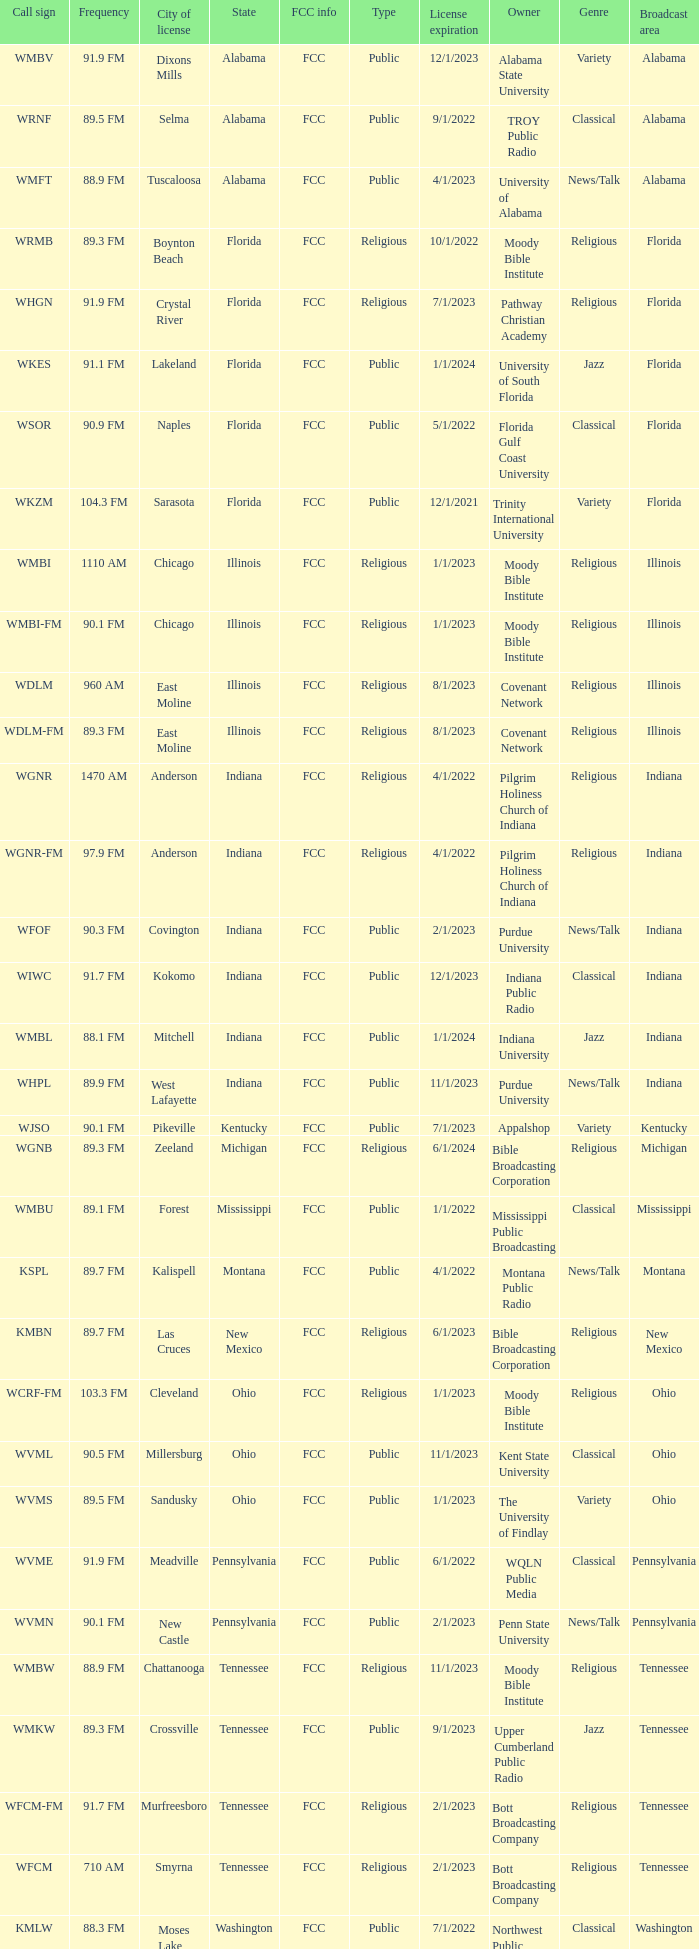What state is the radio station in that has a frequency of 90.1 FM and a city license in New Castle? Pennsylvania. Can you parse all the data within this table? {'header': ['Call sign', 'Frequency', 'City of license', 'State', 'FCC info', 'Type', 'License expiration', 'Owner', 'Genre', 'Broadcast area'], 'rows': [['WMBV', '91.9 FM', 'Dixons Mills', 'Alabama', 'FCC', 'Public', '12/1/2023', 'Alabama State University', 'Variety', 'Alabama'], ['WRNF', '89.5 FM', 'Selma', 'Alabama', 'FCC', 'Public', '9/1/2022', 'TROY Public Radio', 'Classical', 'Alabama'], ['WMFT', '88.9 FM', 'Tuscaloosa', 'Alabama', 'FCC', 'Public', '4/1/2023', 'University of Alabama', 'News/Talk', 'Alabama'], ['WRMB', '89.3 FM', 'Boynton Beach', 'Florida', 'FCC', 'Religious', '10/1/2022', 'Moody Bible Institute', 'Religious', 'Florida'], ['WHGN', '91.9 FM', 'Crystal River', 'Florida', 'FCC', 'Religious', '7/1/2023', 'Pathway Christian Academy', 'Religious', 'Florida'], ['WKES', '91.1 FM', 'Lakeland', 'Florida', 'FCC', 'Public', '1/1/2024', 'University of South Florida', 'Jazz', 'Florida'], ['WSOR', '90.9 FM', 'Naples', 'Florida', 'FCC', 'Public', '5/1/2022', 'Florida Gulf Coast University', 'Classical', 'Florida'], ['WKZM', '104.3 FM', 'Sarasota', 'Florida', 'FCC', 'Public', '12/1/2021', 'Trinity International University', 'Variety', 'Florida'], ['WMBI', '1110 AM', 'Chicago', 'Illinois', 'FCC', 'Religious', '1/1/2023', 'Moody Bible Institute', 'Religious', 'Illinois'], ['WMBI-FM', '90.1 FM', 'Chicago', 'Illinois', 'FCC', 'Religious', '1/1/2023', 'Moody Bible Institute', 'Religious', 'Illinois'], ['WDLM', '960 AM', 'East Moline', 'Illinois', 'FCC', 'Religious', '8/1/2023', 'Covenant Network', 'Religious', 'Illinois'], ['WDLM-FM', '89.3 FM', 'East Moline', 'Illinois', 'FCC', 'Religious', '8/1/2023', 'Covenant Network', 'Religious', 'Illinois'], ['WGNR', '1470 AM', 'Anderson', 'Indiana', 'FCC', 'Religious', '4/1/2022', 'Pilgrim Holiness Church of Indiana', 'Religious', 'Indiana'], ['WGNR-FM', '97.9 FM', 'Anderson', 'Indiana', 'FCC', 'Religious', '4/1/2022', 'Pilgrim Holiness Church of Indiana', 'Religious', 'Indiana'], ['WFOF', '90.3 FM', 'Covington', 'Indiana', 'FCC', 'Public', '2/1/2023', 'Purdue University', 'News/Talk', 'Indiana'], ['WIWC', '91.7 FM', 'Kokomo', 'Indiana', 'FCC', 'Public', '12/1/2023', 'Indiana Public Radio', 'Classical', 'Indiana'], ['WMBL', '88.1 FM', 'Mitchell', 'Indiana', 'FCC', 'Public', '1/1/2024', 'Indiana University', 'Jazz', 'Indiana'], ['WHPL', '89.9 FM', 'West Lafayette', 'Indiana', 'FCC', 'Public', '11/1/2023', 'Purdue University', 'News/Talk', 'Indiana'], ['WJSO', '90.1 FM', 'Pikeville', 'Kentucky', 'FCC', 'Public', '7/1/2023', 'Appalshop', 'Variety', 'Kentucky'], ['WGNB', '89.3 FM', 'Zeeland', 'Michigan', 'FCC', 'Religious', '6/1/2024', 'Bible Broadcasting Corporation', 'Religious', 'Michigan'], ['WMBU', '89.1 FM', 'Forest', 'Mississippi', 'FCC', 'Public', '1/1/2022', 'Mississippi Public Broadcasting', 'Classical', 'Mississippi'], ['KSPL', '89.7 FM', 'Kalispell', 'Montana', 'FCC', 'Public', '4/1/2022', 'Montana Public Radio', 'News/Talk', 'Montana'], ['KMBN', '89.7 FM', 'Las Cruces', 'New Mexico', 'FCC', 'Religious', '6/1/2023', 'Bible Broadcasting Corporation', 'Religious', 'New Mexico'], ['WCRF-FM', '103.3 FM', 'Cleveland', 'Ohio', 'FCC', 'Religious', '1/1/2023', 'Moody Bible Institute', 'Religious', 'Ohio'], ['WVML', '90.5 FM', 'Millersburg', 'Ohio', 'FCC', 'Public', '11/1/2023', 'Kent State University', 'Classical', 'Ohio'], ['WVMS', '89.5 FM', 'Sandusky', 'Ohio', 'FCC', 'Public', '1/1/2023', 'The University of Findlay', 'Variety', 'Ohio'], ['WVME', '91.9 FM', 'Meadville', 'Pennsylvania', 'FCC', 'Public', '6/1/2022', 'WQLN Public Media', 'Classical', 'Pennsylvania'], ['WVMN', '90.1 FM', 'New Castle', 'Pennsylvania', 'FCC', 'Public', '2/1/2023', 'Penn State University', 'News/Talk', 'Pennsylvania'], ['WMBW', '88.9 FM', 'Chattanooga', 'Tennessee', 'FCC', 'Religious', '11/1/2023', 'Moody Bible Institute', 'Religious', 'Tennessee'], ['WMKW', '89.3 FM', 'Crossville', 'Tennessee', 'FCC', 'Public', '9/1/2023', 'Upper Cumberland Public Radio', 'Jazz', 'Tennessee'], ['WFCM-FM', '91.7 FM', 'Murfreesboro', 'Tennessee', 'FCC', 'Religious', '2/1/2023', 'Bott Broadcasting Company', 'Religious', 'Tennessee'], ['WFCM', '710 AM', 'Smyrna', 'Tennessee', 'FCC', 'Religious', '2/1/2023', 'Bott Broadcasting Company', 'Religious', 'Tennessee'], ['KMLW', '88.3 FM', 'Moses Lake', 'Washington', 'FCC', 'Public', '7/1/2022', 'Northwest Public Broadcasting', 'Classical', 'Washington'], ['KMBI', '1330 AM', 'Spokane', 'Washington', 'FCC', 'Religious', '8/1/2023', 'Moody Bible Institute', 'Religious', 'Washington'], ['KMBI-FM', '107.9 FM', 'Spokane', 'Washington', 'FCC', 'Religious', '8/1/2023', 'Moody Bible Institute', 'Religious', 'Washington'], ['KMWY', '91.1 FM', 'Jackson', 'Wyoming', 'FCC', 'Public', '1/1/2023', 'Wyoming Public Media', 'News/Talk', 'Wyoming']]} 